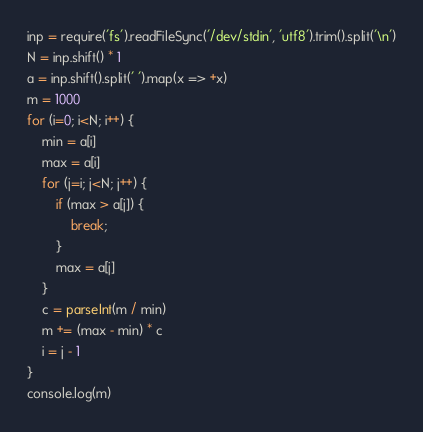Convert code to text. <code><loc_0><loc_0><loc_500><loc_500><_JavaScript_>inp = require('fs').readFileSync('/dev/stdin', 'utf8').trim().split('\n')
N = inp.shift() * 1
a = inp.shift().split(' ').map(x => +x)
m = 1000
for (i=0; i<N; i++) {
    min = a[i]
    max = a[i]
    for (j=i; j<N; j++) {
        if (max > a[j]) {
            break;
        }
        max = a[j]
    }
    c = parseInt(m / min)
    m += (max - min) * c
    i = j - 1
}
console.log(m)</code> 